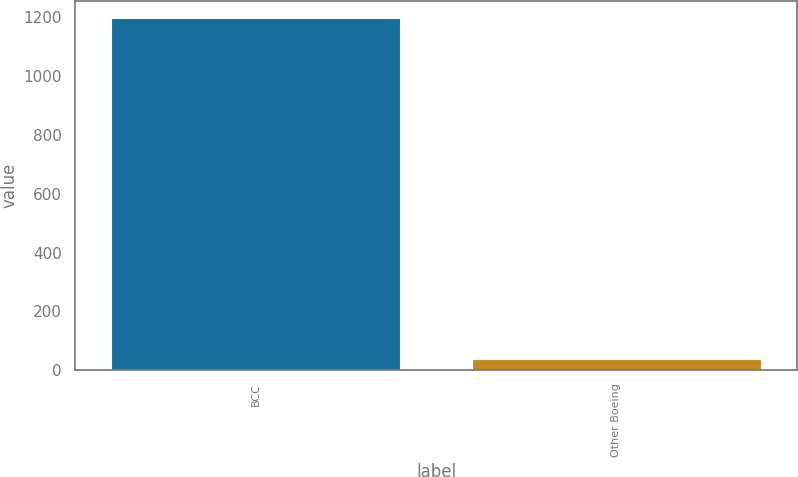Convert chart to OTSL. <chart><loc_0><loc_0><loc_500><loc_500><bar_chart><fcel>BCC<fcel>Other Boeing<nl><fcel>1196<fcel>38<nl></chart> 